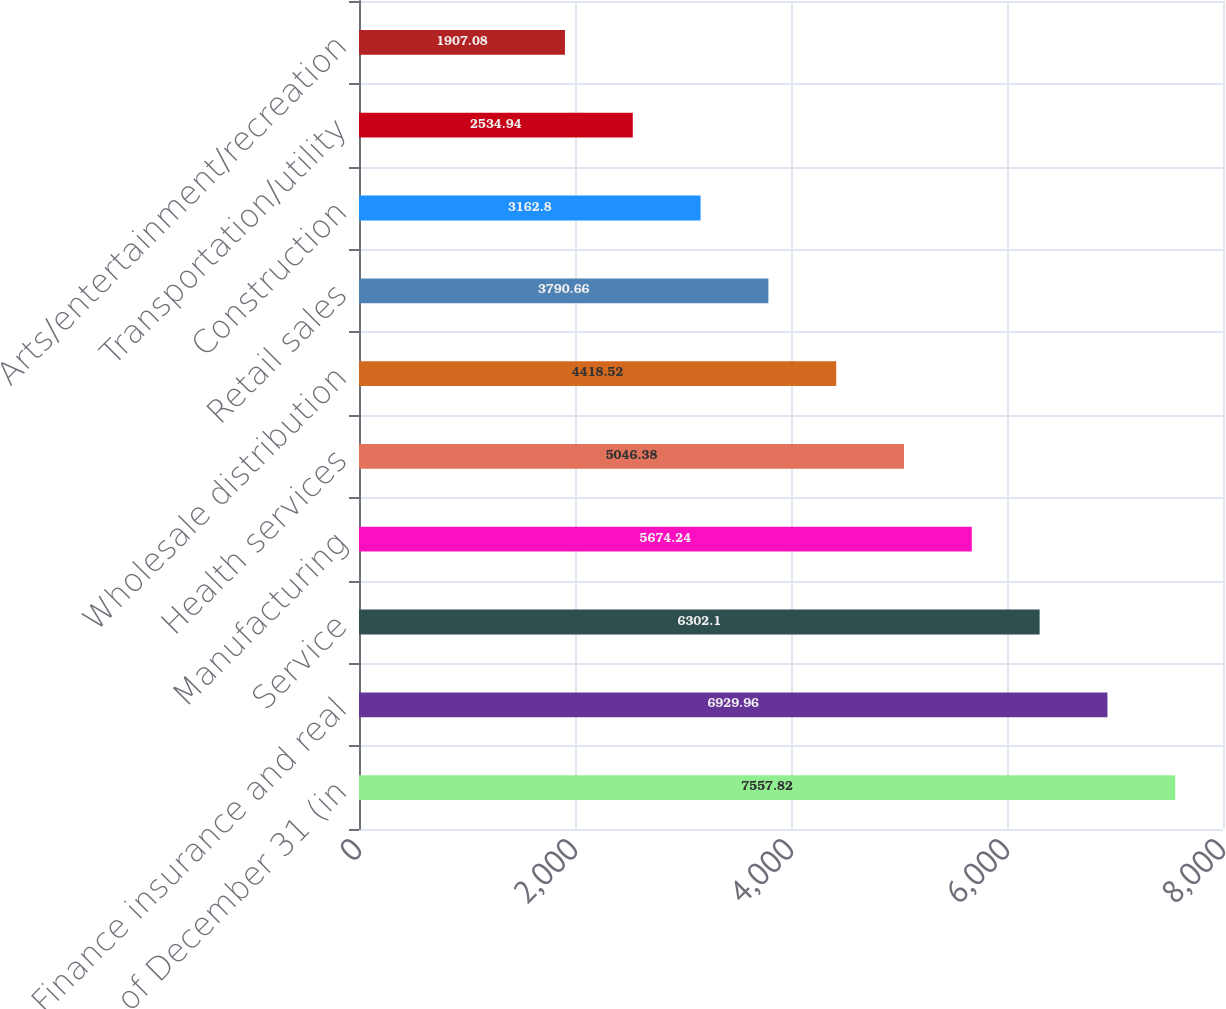Convert chart to OTSL. <chart><loc_0><loc_0><loc_500><loc_500><bar_chart><fcel>As of December 31 (in<fcel>Finance insurance and real<fcel>Service<fcel>Manufacturing<fcel>Health services<fcel>Wholesale distribution<fcel>Retail sales<fcel>Construction<fcel>Transportation/utility<fcel>Arts/entertainment/recreation<nl><fcel>7557.82<fcel>6929.96<fcel>6302.1<fcel>5674.24<fcel>5046.38<fcel>4418.52<fcel>3790.66<fcel>3162.8<fcel>2534.94<fcel>1907.08<nl></chart> 